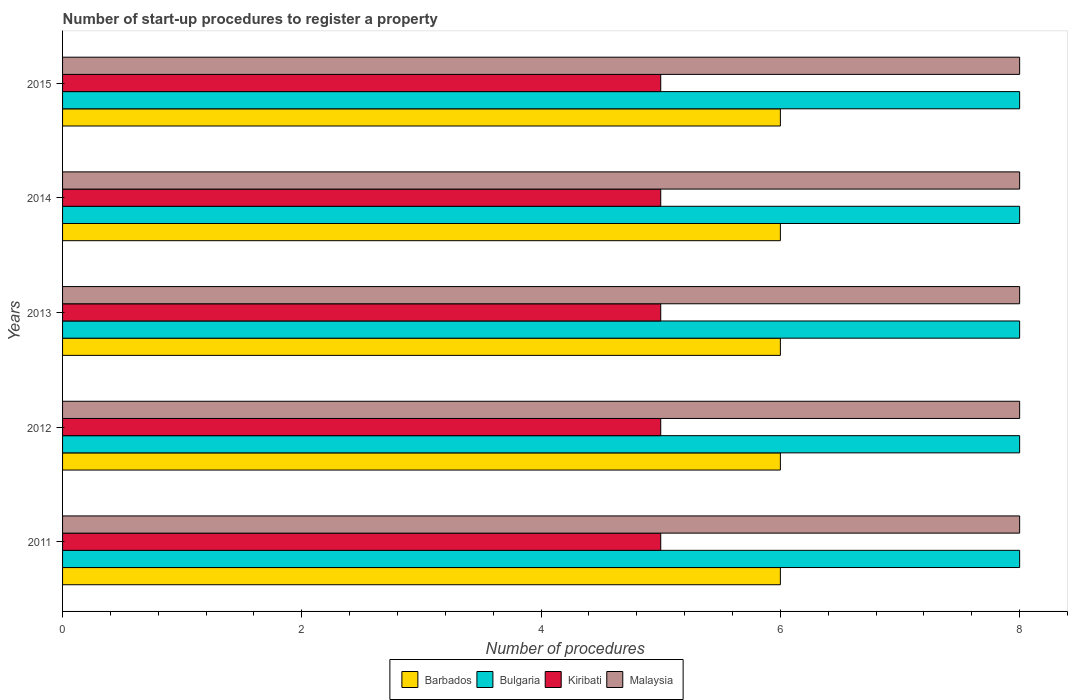How many different coloured bars are there?
Your answer should be compact. 4. How many groups of bars are there?
Ensure brevity in your answer.  5. What is the label of the 1st group of bars from the top?
Make the answer very short. 2015. What is the number of procedures required to register a property in Malaysia in 2011?
Ensure brevity in your answer.  8. Across all years, what is the maximum number of procedures required to register a property in Bulgaria?
Make the answer very short. 8. Across all years, what is the minimum number of procedures required to register a property in Malaysia?
Provide a succinct answer. 8. In which year was the number of procedures required to register a property in Bulgaria maximum?
Your answer should be very brief. 2011. In which year was the number of procedures required to register a property in Barbados minimum?
Ensure brevity in your answer.  2011. What is the total number of procedures required to register a property in Bulgaria in the graph?
Give a very brief answer. 40. What is the difference between the number of procedures required to register a property in Bulgaria in 2013 and that in 2014?
Offer a terse response. 0. What is the difference between the number of procedures required to register a property in Kiribati in 2014 and the number of procedures required to register a property in Barbados in 2013?
Give a very brief answer. -1. In the year 2011, what is the difference between the number of procedures required to register a property in Kiribati and number of procedures required to register a property in Bulgaria?
Your response must be concise. -3. In how many years, is the number of procedures required to register a property in Kiribati greater than 8 ?
Give a very brief answer. 0. What is the ratio of the number of procedures required to register a property in Bulgaria in 2012 to that in 2015?
Your answer should be very brief. 1. Is the number of procedures required to register a property in Bulgaria in 2011 less than that in 2012?
Offer a very short reply. No. What is the difference between the highest and the lowest number of procedures required to register a property in Kiribati?
Keep it short and to the point. 0. Is the sum of the number of procedures required to register a property in Barbados in 2011 and 2012 greater than the maximum number of procedures required to register a property in Malaysia across all years?
Your answer should be compact. Yes. Is it the case that in every year, the sum of the number of procedures required to register a property in Barbados and number of procedures required to register a property in Bulgaria is greater than the sum of number of procedures required to register a property in Kiribati and number of procedures required to register a property in Malaysia?
Make the answer very short. No. What does the 4th bar from the top in 2014 represents?
Your answer should be very brief. Barbados. What does the 1st bar from the bottom in 2015 represents?
Provide a short and direct response. Barbados. Is it the case that in every year, the sum of the number of procedures required to register a property in Barbados and number of procedures required to register a property in Bulgaria is greater than the number of procedures required to register a property in Kiribati?
Your answer should be very brief. Yes. How many bars are there?
Your answer should be compact. 20. How many years are there in the graph?
Keep it short and to the point. 5. What is the difference between two consecutive major ticks on the X-axis?
Your response must be concise. 2. Are the values on the major ticks of X-axis written in scientific E-notation?
Your response must be concise. No. Does the graph contain any zero values?
Keep it short and to the point. No. What is the title of the graph?
Offer a terse response. Number of start-up procedures to register a property. What is the label or title of the X-axis?
Offer a very short reply. Number of procedures. What is the Number of procedures in Bulgaria in 2011?
Give a very brief answer. 8. What is the Number of procedures of Barbados in 2012?
Your answer should be very brief. 6. What is the Number of procedures in Kiribati in 2012?
Your answer should be very brief. 5. What is the Number of procedures in Malaysia in 2012?
Provide a succinct answer. 8. What is the Number of procedures in Bulgaria in 2013?
Keep it short and to the point. 8. What is the Number of procedures of Malaysia in 2013?
Your response must be concise. 8. What is the Number of procedures of Kiribati in 2014?
Make the answer very short. 5. What is the Number of procedures in Barbados in 2015?
Offer a very short reply. 6. What is the Number of procedures of Bulgaria in 2015?
Your answer should be compact. 8. What is the Number of procedures of Kiribati in 2015?
Your answer should be compact. 5. Across all years, what is the maximum Number of procedures in Barbados?
Your answer should be compact. 6. Across all years, what is the maximum Number of procedures of Bulgaria?
Keep it short and to the point. 8. Across all years, what is the maximum Number of procedures of Kiribati?
Offer a very short reply. 5. What is the total Number of procedures in Barbados in the graph?
Offer a terse response. 30. What is the total Number of procedures in Malaysia in the graph?
Your response must be concise. 40. What is the difference between the Number of procedures in Kiribati in 2011 and that in 2012?
Keep it short and to the point. 0. What is the difference between the Number of procedures of Malaysia in 2011 and that in 2012?
Your answer should be very brief. 0. What is the difference between the Number of procedures of Bulgaria in 2011 and that in 2013?
Offer a terse response. 0. What is the difference between the Number of procedures of Kiribati in 2011 and that in 2013?
Provide a short and direct response. 0. What is the difference between the Number of procedures in Malaysia in 2011 and that in 2013?
Ensure brevity in your answer.  0. What is the difference between the Number of procedures of Barbados in 2011 and that in 2014?
Provide a short and direct response. 0. What is the difference between the Number of procedures in Kiribati in 2011 and that in 2014?
Your answer should be very brief. 0. What is the difference between the Number of procedures in Bulgaria in 2011 and that in 2015?
Provide a short and direct response. 0. What is the difference between the Number of procedures in Barbados in 2012 and that in 2013?
Give a very brief answer. 0. What is the difference between the Number of procedures in Bulgaria in 2012 and that in 2013?
Ensure brevity in your answer.  0. What is the difference between the Number of procedures in Kiribati in 2012 and that in 2013?
Make the answer very short. 0. What is the difference between the Number of procedures in Kiribati in 2012 and that in 2015?
Give a very brief answer. 0. What is the difference between the Number of procedures of Malaysia in 2012 and that in 2015?
Offer a terse response. 0. What is the difference between the Number of procedures in Barbados in 2013 and that in 2014?
Your answer should be compact. 0. What is the difference between the Number of procedures of Kiribati in 2013 and that in 2014?
Offer a very short reply. 0. What is the difference between the Number of procedures of Malaysia in 2013 and that in 2014?
Your response must be concise. 0. What is the difference between the Number of procedures in Kiribati in 2013 and that in 2015?
Keep it short and to the point. 0. What is the difference between the Number of procedures of Barbados in 2014 and that in 2015?
Keep it short and to the point. 0. What is the difference between the Number of procedures of Bulgaria in 2014 and that in 2015?
Offer a terse response. 0. What is the difference between the Number of procedures in Kiribati in 2014 and that in 2015?
Keep it short and to the point. 0. What is the difference between the Number of procedures of Malaysia in 2014 and that in 2015?
Your answer should be compact. 0. What is the difference between the Number of procedures in Barbados in 2011 and the Number of procedures in Bulgaria in 2012?
Offer a very short reply. -2. What is the difference between the Number of procedures in Barbados in 2011 and the Number of procedures in Kiribati in 2012?
Keep it short and to the point. 1. What is the difference between the Number of procedures of Bulgaria in 2011 and the Number of procedures of Kiribati in 2012?
Your response must be concise. 3. What is the difference between the Number of procedures in Bulgaria in 2011 and the Number of procedures in Malaysia in 2012?
Provide a short and direct response. 0. What is the difference between the Number of procedures of Barbados in 2011 and the Number of procedures of Kiribati in 2013?
Provide a succinct answer. 1. What is the difference between the Number of procedures in Bulgaria in 2011 and the Number of procedures in Kiribati in 2013?
Make the answer very short. 3. What is the difference between the Number of procedures in Barbados in 2011 and the Number of procedures in Bulgaria in 2014?
Keep it short and to the point. -2. What is the difference between the Number of procedures in Barbados in 2011 and the Number of procedures in Bulgaria in 2015?
Keep it short and to the point. -2. What is the difference between the Number of procedures in Barbados in 2011 and the Number of procedures in Malaysia in 2015?
Ensure brevity in your answer.  -2. What is the difference between the Number of procedures in Barbados in 2012 and the Number of procedures in Kiribati in 2013?
Your answer should be very brief. 1. What is the difference between the Number of procedures of Barbados in 2012 and the Number of procedures of Malaysia in 2013?
Your answer should be compact. -2. What is the difference between the Number of procedures in Kiribati in 2012 and the Number of procedures in Malaysia in 2013?
Offer a terse response. -3. What is the difference between the Number of procedures in Barbados in 2012 and the Number of procedures in Kiribati in 2014?
Offer a very short reply. 1. What is the difference between the Number of procedures in Barbados in 2012 and the Number of procedures in Malaysia in 2014?
Your response must be concise. -2. What is the difference between the Number of procedures in Bulgaria in 2012 and the Number of procedures in Malaysia in 2014?
Your answer should be very brief. 0. What is the difference between the Number of procedures in Kiribati in 2012 and the Number of procedures in Malaysia in 2014?
Offer a very short reply. -3. What is the difference between the Number of procedures of Barbados in 2012 and the Number of procedures of Kiribati in 2015?
Provide a succinct answer. 1. What is the difference between the Number of procedures of Bulgaria in 2012 and the Number of procedures of Kiribati in 2015?
Your answer should be very brief. 3. What is the difference between the Number of procedures of Barbados in 2013 and the Number of procedures of Kiribati in 2014?
Provide a short and direct response. 1. What is the difference between the Number of procedures of Bulgaria in 2013 and the Number of procedures of Kiribati in 2014?
Offer a very short reply. 3. What is the difference between the Number of procedures in Bulgaria in 2013 and the Number of procedures in Malaysia in 2014?
Offer a very short reply. 0. What is the difference between the Number of procedures of Kiribati in 2013 and the Number of procedures of Malaysia in 2014?
Provide a short and direct response. -3. What is the difference between the Number of procedures in Barbados in 2013 and the Number of procedures in Bulgaria in 2015?
Your answer should be compact. -2. What is the difference between the Number of procedures in Bulgaria in 2013 and the Number of procedures in Kiribati in 2015?
Offer a very short reply. 3. What is the difference between the Number of procedures in Bulgaria in 2013 and the Number of procedures in Malaysia in 2015?
Provide a succinct answer. 0. What is the difference between the Number of procedures of Barbados in 2014 and the Number of procedures of Bulgaria in 2015?
Give a very brief answer. -2. What is the difference between the Number of procedures of Bulgaria in 2014 and the Number of procedures of Kiribati in 2015?
Provide a short and direct response. 3. What is the difference between the Number of procedures in Kiribati in 2014 and the Number of procedures in Malaysia in 2015?
Your answer should be very brief. -3. What is the average Number of procedures of Barbados per year?
Ensure brevity in your answer.  6. What is the average Number of procedures in Kiribati per year?
Your answer should be compact. 5. In the year 2011, what is the difference between the Number of procedures of Barbados and Number of procedures of Bulgaria?
Offer a terse response. -2. In the year 2011, what is the difference between the Number of procedures of Bulgaria and Number of procedures of Kiribati?
Your answer should be very brief. 3. In the year 2011, what is the difference between the Number of procedures in Kiribati and Number of procedures in Malaysia?
Your response must be concise. -3. In the year 2012, what is the difference between the Number of procedures in Barbados and Number of procedures in Bulgaria?
Your response must be concise. -2. In the year 2012, what is the difference between the Number of procedures of Bulgaria and Number of procedures of Malaysia?
Offer a very short reply. 0. In the year 2013, what is the difference between the Number of procedures of Barbados and Number of procedures of Bulgaria?
Provide a succinct answer. -2. In the year 2013, what is the difference between the Number of procedures of Barbados and Number of procedures of Kiribati?
Your response must be concise. 1. In the year 2013, what is the difference between the Number of procedures in Bulgaria and Number of procedures in Kiribati?
Your answer should be very brief. 3. In the year 2014, what is the difference between the Number of procedures of Barbados and Number of procedures of Bulgaria?
Offer a very short reply. -2. In the year 2014, what is the difference between the Number of procedures of Barbados and Number of procedures of Kiribati?
Make the answer very short. 1. In the year 2014, what is the difference between the Number of procedures in Kiribati and Number of procedures in Malaysia?
Ensure brevity in your answer.  -3. In the year 2015, what is the difference between the Number of procedures of Barbados and Number of procedures of Bulgaria?
Your answer should be compact. -2. In the year 2015, what is the difference between the Number of procedures of Barbados and Number of procedures of Malaysia?
Ensure brevity in your answer.  -2. What is the ratio of the Number of procedures in Barbados in 2011 to that in 2012?
Offer a very short reply. 1. What is the ratio of the Number of procedures of Bulgaria in 2011 to that in 2012?
Provide a succinct answer. 1. What is the ratio of the Number of procedures in Malaysia in 2011 to that in 2012?
Keep it short and to the point. 1. What is the ratio of the Number of procedures of Malaysia in 2011 to that in 2013?
Offer a very short reply. 1. What is the ratio of the Number of procedures in Barbados in 2011 to that in 2014?
Provide a succinct answer. 1. What is the ratio of the Number of procedures in Kiribati in 2011 to that in 2014?
Your answer should be compact. 1. What is the ratio of the Number of procedures of Malaysia in 2011 to that in 2014?
Make the answer very short. 1. What is the ratio of the Number of procedures of Kiribati in 2011 to that in 2015?
Offer a terse response. 1. What is the ratio of the Number of procedures of Malaysia in 2012 to that in 2013?
Keep it short and to the point. 1. What is the ratio of the Number of procedures of Barbados in 2012 to that in 2014?
Keep it short and to the point. 1. What is the ratio of the Number of procedures in Bulgaria in 2012 to that in 2014?
Provide a short and direct response. 1. What is the ratio of the Number of procedures of Kiribati in 2012 to that in 2014?
Provide a short and direct response. 1. What is the ratio of the Number of procedures of Bulgaria in 2012 to that in 2015?
Keep it short and to the point. 1. What is the ratio of the Number of procedures of Kiribati in 2012 to that in 2015?
Your response must be concise. 1. What is the ratio of the Number of procedures of Malaysia in 2012 to that in 2015?
Your answer should be very brief. 1. What is the ratio of the Number of procedures in Malaysia in 2013 to that in 2014?
Offer a very short reply. 1. What is the ratio of the Number of procedures of Barbados in 2013 to that in 2015?
Your response must be concise. 1. What is the ratio of the Number of procedures of Malaysia in 2013 to that in 2015?
Keep it short and to the point. 1. What is the ratio of the Number of procedures in Barbados in 2014 to that in 2015?
Make the answer very short. 1. What is the ratio of the Number of procedures of Kiribati in 2014 to that in 2015?
Your answer should be very brief. 1. What is the ratio of the Number of procedures in Malaysia in 2014 to that in 2015?
Your answer should be very brief. 1. What is the difference between the highest and the second highest Number of procedures in Barbados?
Offer a very short reply. 0. What is the difference between the highest and the second highest Number of procedures in Kiribati?
Give a very brief answer. 0. What is the difference between the highest and the second highest Number of procedures of Malaysia?
Offer a terse response. 0. What is the difference between the highest and the lowest Number of procedures in Kiribati?
Offer a terse response. 0. 